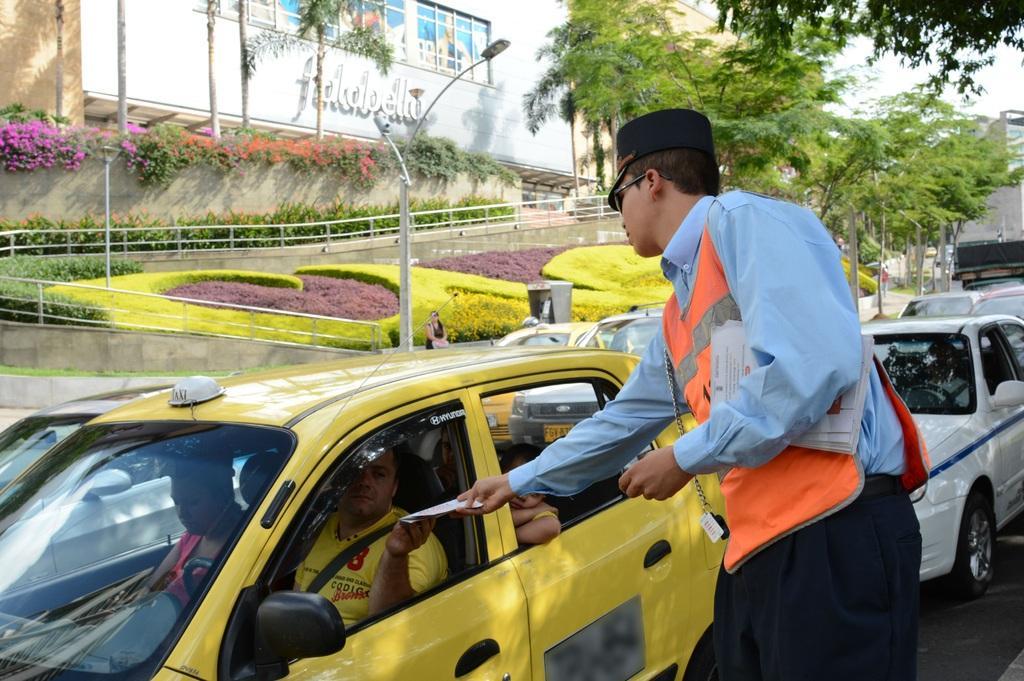How would you summarize this image in a sentence or two? This picture is clicked outside the city. In this picture, we see the men are riding the yellow car. We see a man in the white shirt and orange jacket is holding the papers and he is distributing the papers. Behind them, we see many cars are moving on the road. In the middle of the picture, we see the woman is standing. Beside her, we see the street lights and beside that, we see the railing and we even see the grass and the shrubs. On the left side, we see the plants which have pink and red flowers. Beside that, we see a building. There are trees and buildings in the background. 